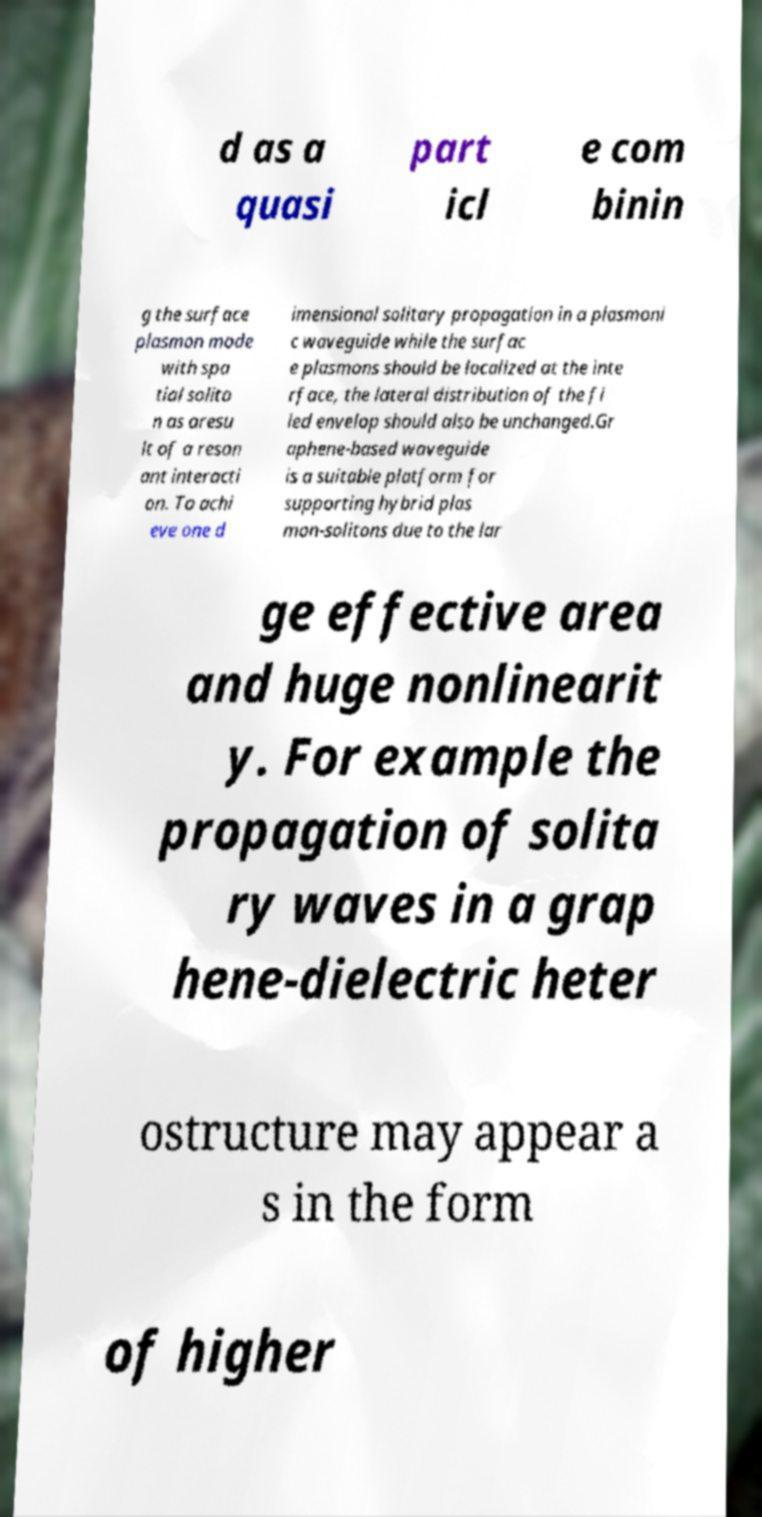Can you read and provide the text displayed in the image?This photo seems to have some interesting text. Can you extract and type it out for me? d as a quasi part icl e com binin g the surface plasmon mode with spa tial solito n as aresu lt of a reson ant interacti on. To achi eve one d imensional solitary propagation in a plasmoni c waveguide while the surfac e plasmons should be localized at the inte rface, the lateral distribution of the fi led envelop should also be unchanged.Gr aphene-based waveguide is a suitable platform for supporting hybrid plas mon-solitons due to the lar ge effective area and huge nonlinearit y. For example the propagation of solita ry waves in a grap hene-dielectric heter ostructure may appear a s in the form of higher 